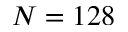Convert formula to latex. <formula><loc_0><loc_0><loc_500><loc_500>N = 1 2 8</formula> 